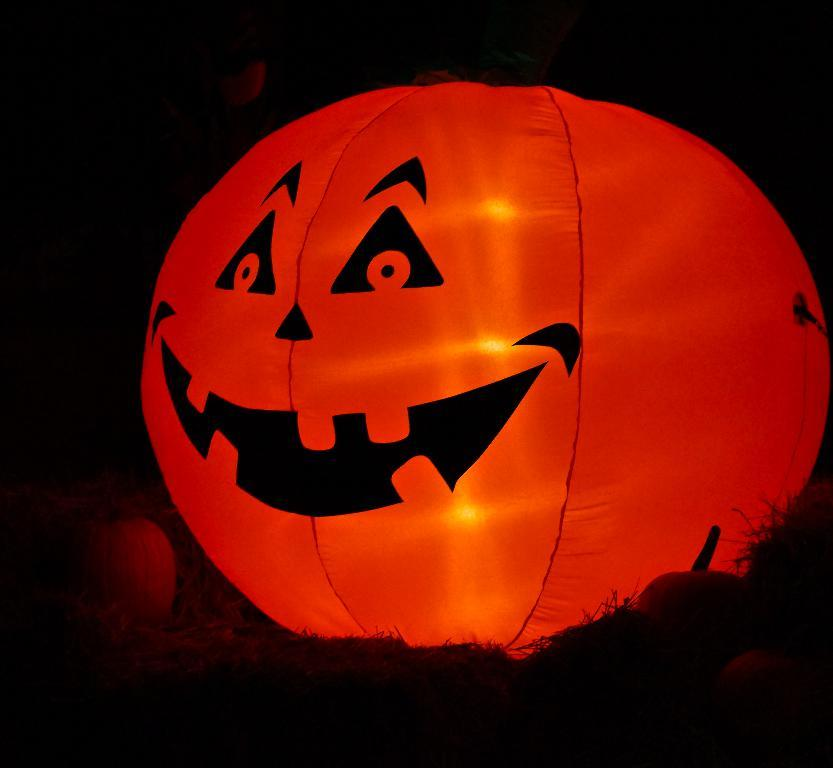What is the overall lighting condition of the image? The image is dark. What color is the pumpkin in the image? There is a red pumpkin in the image. Are there any sources of light visible in the image? Yes, there are lights present in the image. How many eyes can be seen on the pumpkin in the image? There are no eyes visible on the pumpkin in the image, as it is a pumpkin and not a living creature. 